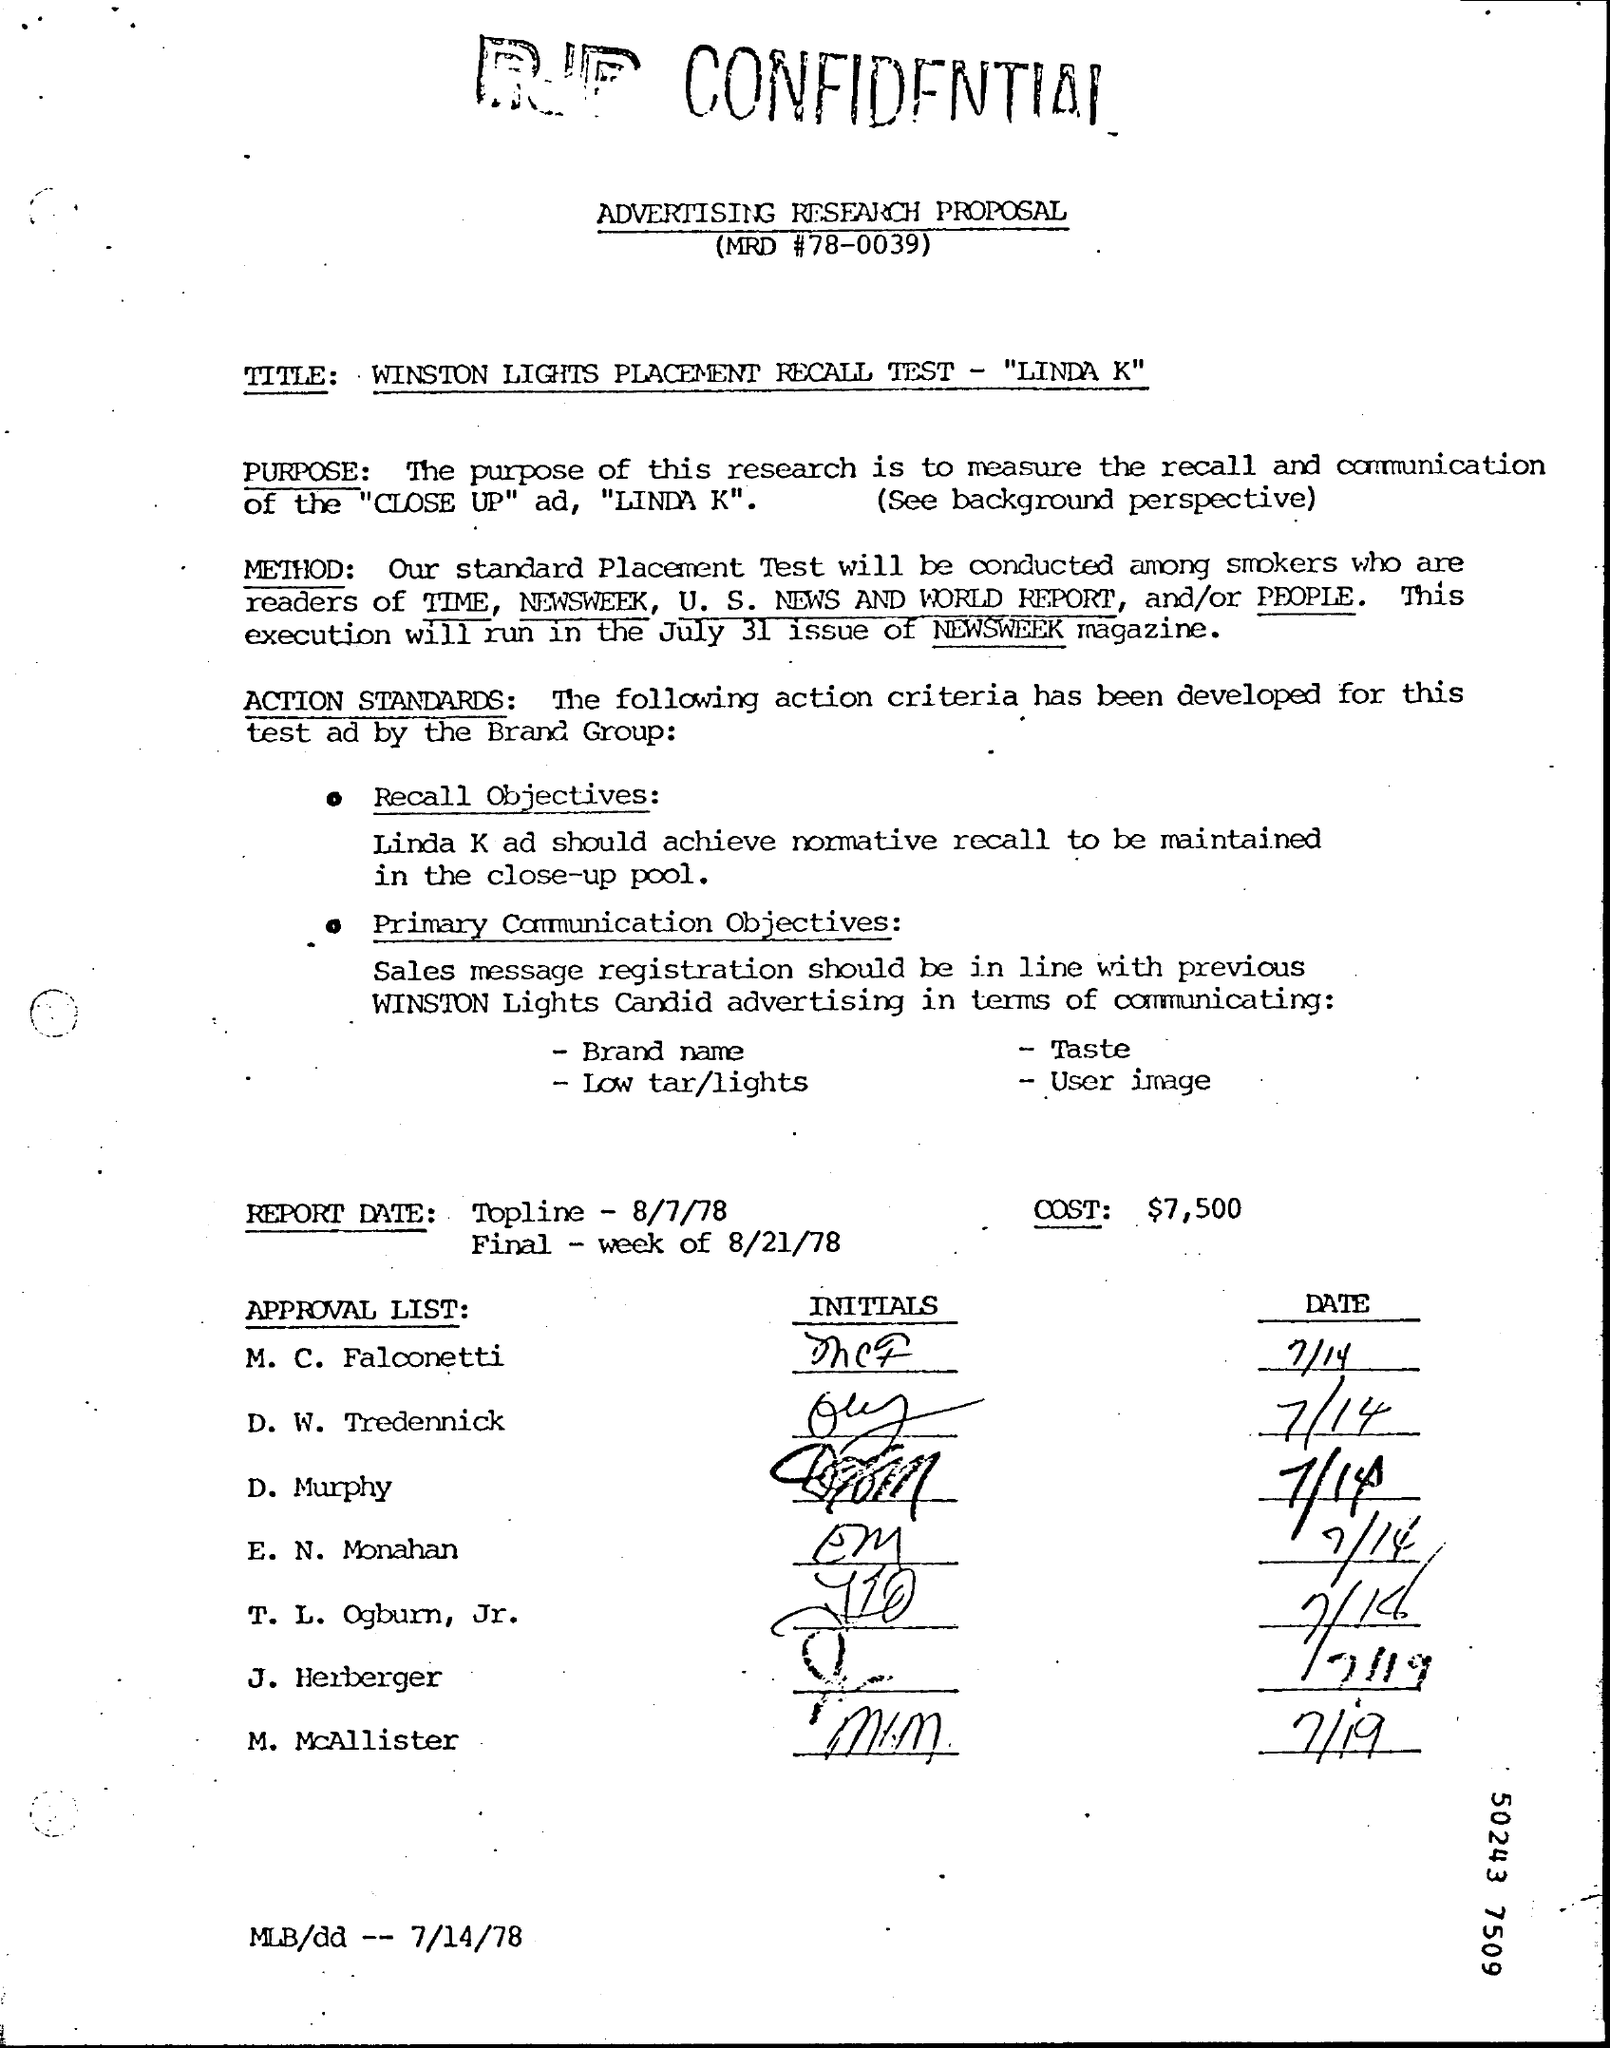What is the MRD #?
Give a very brief answer. 78-0039. What is the Brand Name?
Provide a short and direct response. Taste. What is the Low tar/lights?
Your answer should be compact. User Image. What is the Report Date Topline?
Provide a succinct answer. 8/7/78. What is the Report Date Final?
Make the answer very short. Week of 8/21/78. What is the Cost?
Give a very brief answer. 7,500. 